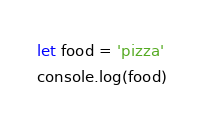Convert code to text. <code><loc_0><loc_0><loc_500><loc_500><_JavaScript_>let food = 'pizza'
console.log(food)


</code> 